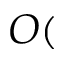Convert formula to latex. <formula><loc_0><loc_0><loc_500><loc_500>O (</formula> 